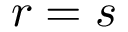<formula> <loc_0><loc_0><loc_500><loc_500>r = s</formula> 